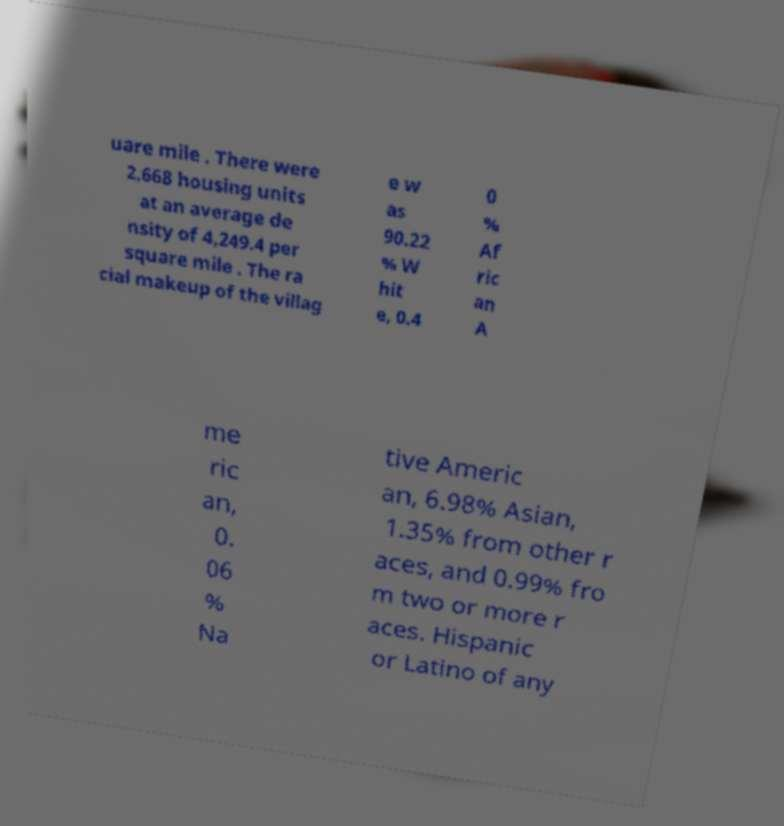Please identify and transcribe the text found in this image. uare mile . There were 2,668 housing units at an average de nsity of 4,249.4 per square mile . The ra cial makeup of the villag e w as 90.22 % W hit e, 0.4 0 % Af ric an A me ric an, 0. 06 % Na tive Americ an, 6.98% Asian, 1.35% from other r aces, and 0.99% fro m two or more r aces. Hispanic or Latino of any 